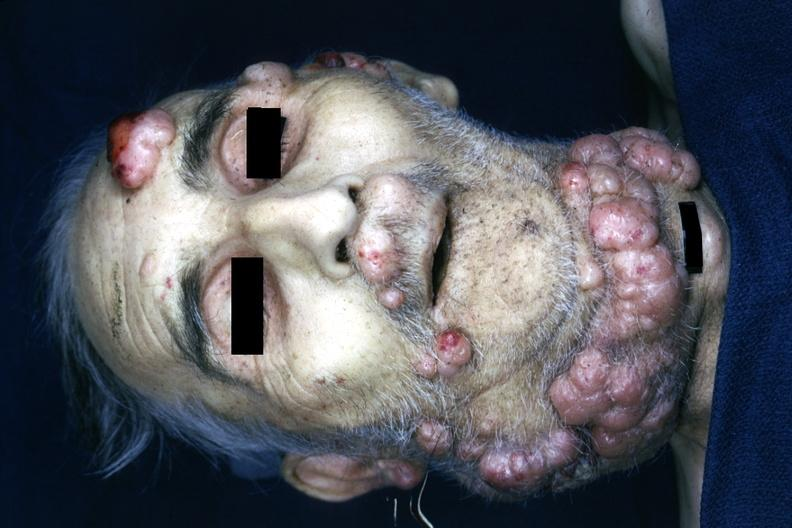does von recklinghausen disease is present?
Answer the question using a single word or phrase. Yes 